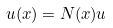Convert formula to latex. <formula><loc_0><loc_0><loc_500><loc_500>u ( x ) = N ( x ) u</formula> 